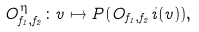<formula> <loc_0><loc_0><loc_500><loc_500>O ^ { \eta } _ { f _ { 1 } , f _ { 2 } } \colon v \mapsto P ( O _ { f _ { 1 } , f _ { 2 } } i ( v ) ) ,</formula> 